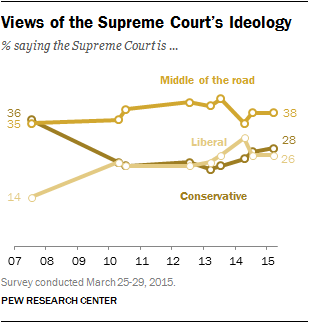Point out several critical features in this image. According to a recent survey, the ideology of the Supreme Court is currently classified as conservative, with a strong influence in 15 out of 28 justices. In 2007, 50% of respondents reported that the ideology of the Supreme Court was either liberal or conservative. 